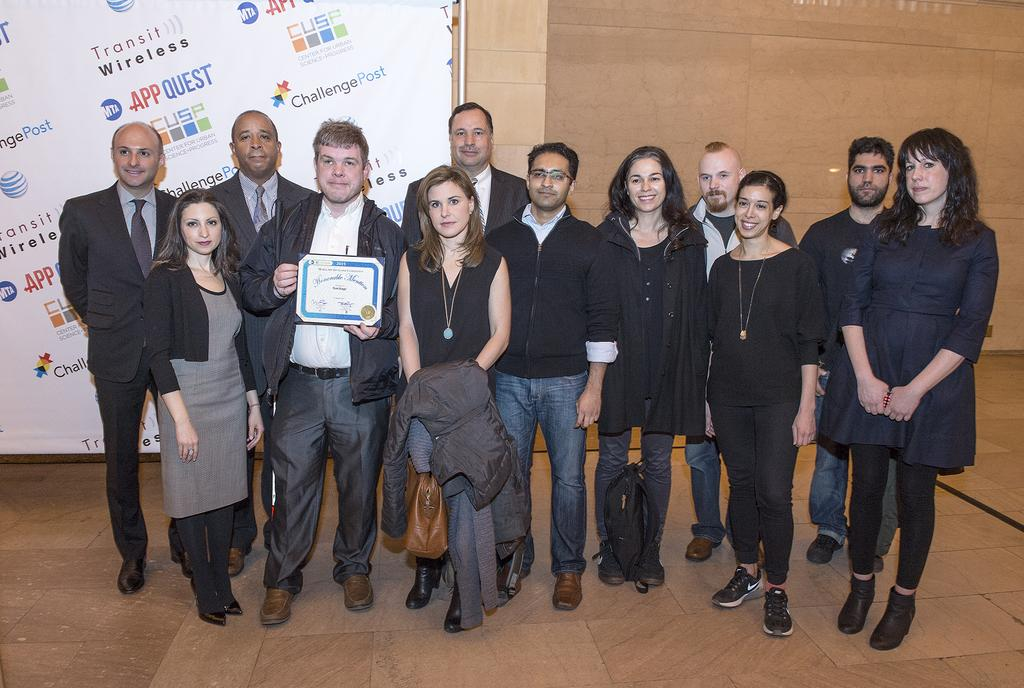What is the main focus of the image? The main focus of the image is the people in the center. Can you describe anything else in the image besides the people? Yes, there is a poster on the wall on the left side of the image. Where is the drawer located in the image? There is no drawer present in the image. What type of rose can be seen in the image? There are no roses present in the image. 